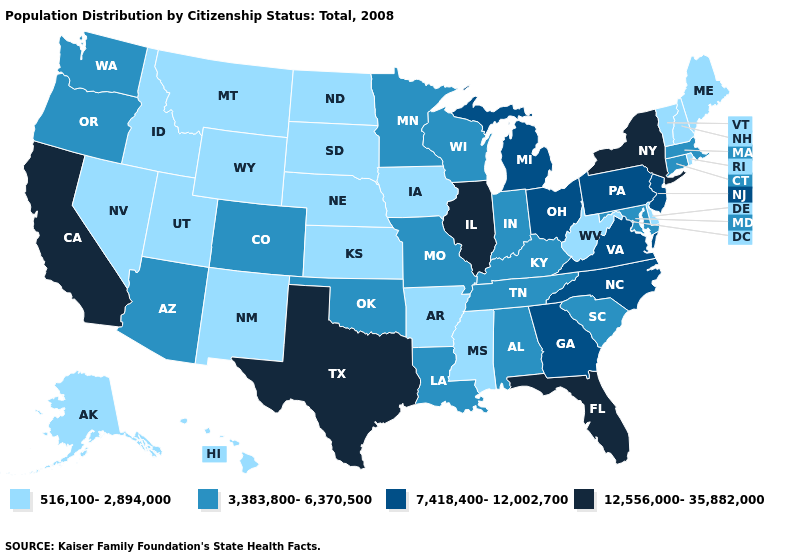What is the lowest value in the USA?
Give a very brief answer. 516,100-2,894,000. Which states have the highest value in the USA?
Concise answer only. California, Florida, Illinois, New York, Texas. What is the value of California?
Be succinct. 12,556,000-35,882,000. What is the lowest value in states that border South Carolina?
Answer briefly. 7,418,400-12,002,700. What is the value of Illinois?
Answer briefly. 12,556,000-35,882,000. Which states have the highest value in the USA?
Write a very short answer. California, Florida, Illinois, New York, Texas. Name the states that have a value in the range 12,556,000-35,882,000?
Short answer required. California, Florida, Illinois, New York, Texas. Among the states that border Missouri , which have the highest value?
Quick response, please. Illinois. What is the value of Virginia?
Short answer required. 7,418,400-12,002,700. Name the states that have a value in the range 3,383,800-6,370,500?
Short answer required. Alabama, Arizona, Colorado, Connecticut, Indiana, Kentucky, Louisiana, Maryland, Massachusetts, Minnesota, Missouri, Oklahoma, Oregon, South Carolina, Tennessee, Washington, Wisconsin. How many symbols are there in the legend?
Be succinct. 4. How many symbols are there in the legend?
Short answer required. 4. What is the value of South Carolina?
Keep it brief. 3,383,800-6,370,500. Name the states that have a value in the range 516,100-2,894,000?
Answer briefly. Alaska, Arkansas, Delaware, Hawaii, Idaho, Iowa, Kansas, Maine, Mississippi, Montana, Nebraska, Nevada, New Hampshire, New Mexico, North Dakota, Rhode Island, South Dakota, Utah, Vermont, West Virginia, Wyoming. Name the states that have a value in the range 3,383,800-6,370,500?
Keep it brief. Alabama, Arizona, Colorado, Connecticut, Indiana, Kentucky, Louisiana, Maryland, Massachusetts, Minnesota, Missouri, Oklahoma, Oregon, South Carolina, Tennessee, Washington, Wisconsin. 